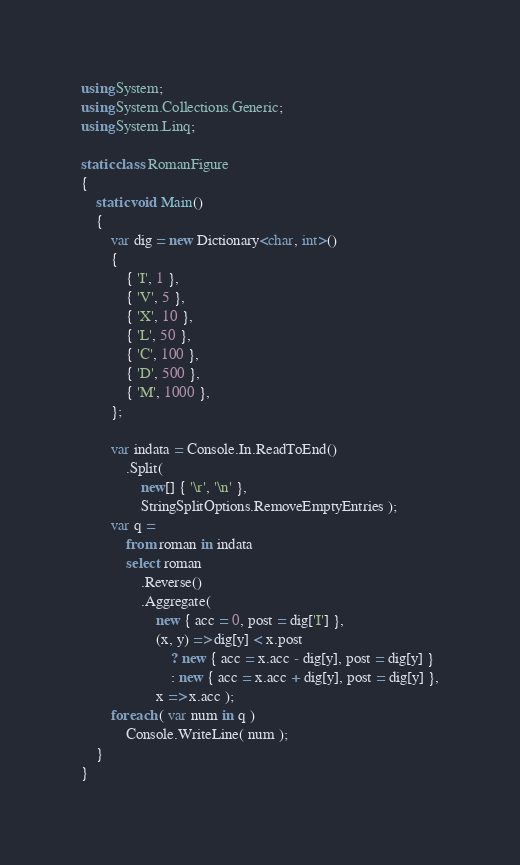Convert code to text. <code><loc_0><loc_0><loc_500><loc_500><_C#_>using System;
using System.Collections.Generic;
using System.Linq;

static class RomanFigure
{
    static void Main()
    {
        var dig = new Dictionary<char, int>()
        {
            { 'I', 1 },
            { 'V', 5 },
            { 'X', 10 },
            { 'L', 50 },
            { 'C', 100 },
            { 'D', 500 },
            { 'M', 1000 },
        };

        var indata = Console.In.ReadToEnd()
            .Split( 
                new[] { '\r', '\n' },
                StringSplitOptions.RemoveEmptyEntries );
        var q =
            from roman in indata
            select roman
                .Reverse()
                .Aggregate( 
                    new { acc = 0, post = dig['I'] }, 
                    (x, y) => dig[y] < x.post
                        ? new { acc = x.acc - dig[y], post = dig[y] }
                        : new { acc = x.acc + dig[y], post = dig[y] },
                    x => x.acc );
        foreach ( var num in q )
            Console.WriteLine( num );
    }
}</code> 